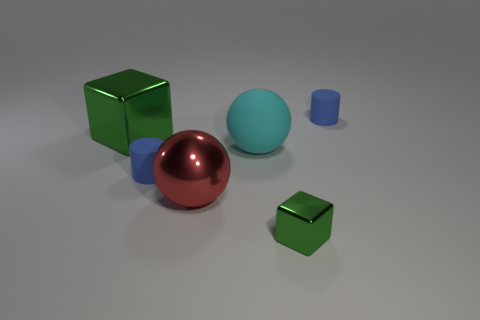Is there a tiny object on the left side of the green shiny cube right of the large green shiny thing?
Offer a terse response. Yes. There is a metallic thing that is behind the shiny ball; how many big matte spheres are to the left of it?
Your response must be concise. 0. What material is the other cyan sphere that is the same size as the shiny ball?
Provide a succinct answer. Rubber. There is a red object that is in front of the large green cube; is its shape the same as the large matte object?
Your answer should be very brief. Yes. Are there more small green metallic blocks behind the big green object than objects that are to the right of the big red thing?
Your answer should be very brief. No. What number of tiny blocks have the same material as the big red object?
Your answer should be very brief. 1. Does the metallic ball have the same size as the cyan rubber sphere?
Provide a short and direct response. Yes. The big rubber ball is what color?
Give a very brief answer. Cyan. What number of things are either small green metallic objects or big spheres?
Offer a very short reply. 3. Are there any other tiny shiny things that have the same shape as the cyan thing?
Make the answer very short. No. 